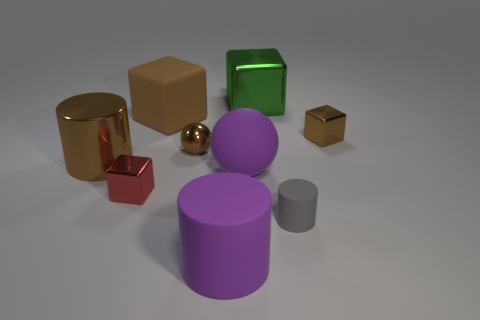Is there anything else that is the same color as the metallic sphere?
Your response must be concise. Yes. Do the brown thing that is on the right side of the small rubber cylinder and the sphere in front of the large brown metallic cylinder have the same size?
Offer a very short reply. No. Is the number of large green metallic objects in front of the small sphere the same as the number of large rubber cylinders in front of the small gray matte object?
Provide a short and direct response. No. There is a brown metal block; does it have the same size as the cube that is behind the big brown matte cube?
Provide a short and direct response. No. Are there any large brown objects that are left of the large cylinder in front of the tiny gray rubber thing?
Keep it short and to the point. Yes. Are there any large red metallic things of the same shape as the tiny red metallic thing?
Ensure brevity in your answer.  No. How many cubes are left of the tiny cube that is on the right side of the matte cylinder to the left of the rubber ball?
Keep it short and to the point. 3. There is a matte ball; is it the same color as the large cylinder that is on the right side of the big matte block?
Your answer should be very brief. Yes. How many things are large purple matte things that are behind the purple cylinder or brown cylinders that are in front of the small brown cube?
Make the answer very short. 2. Are there more red shiny objects behind the small red block than brown matte cubes that are on the right side of the big green metallic thing?
Give a very brief answer. No. 